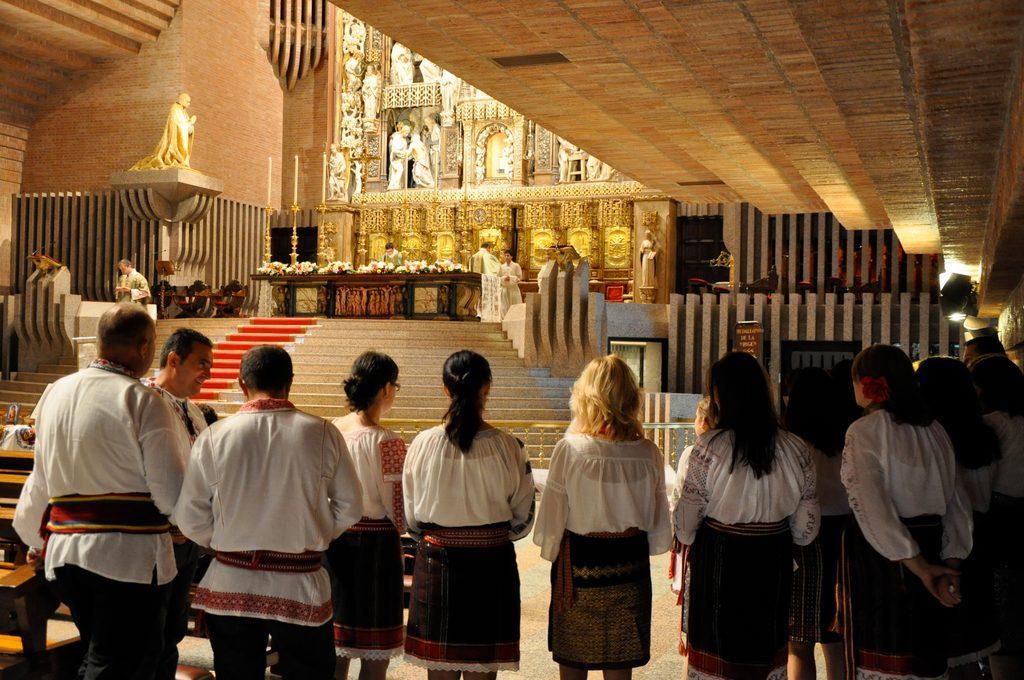Could you give a brief overview of what you see in this image? As we can see in the image there are few people, stairs, statues, tables and a wall. 